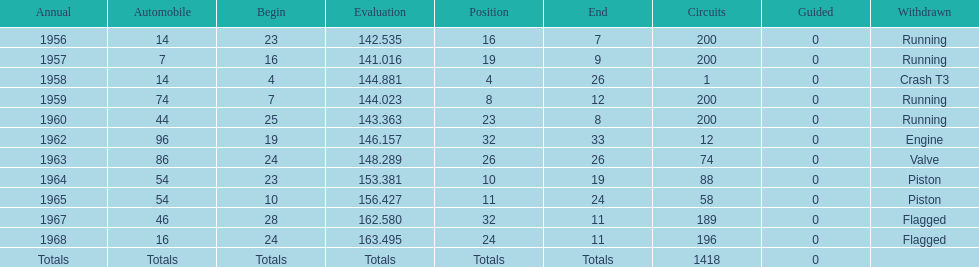How many times was bob veith ranked higher than 10 at an indy 500? 2. 